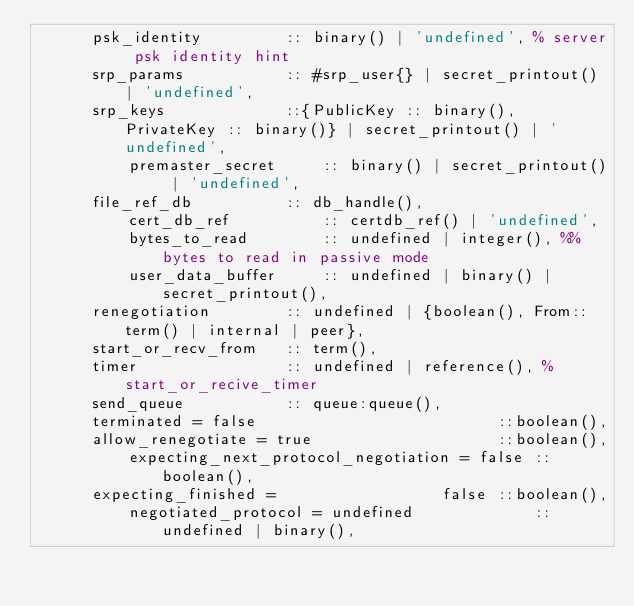Convert code to text. <code><loc_0><loc_0><loc_500><loc_500><_Erlang_>	  psk_identity         :: binary() | 'undefined', % server psk identity hint
	  srp_params           :: #srp_user{} | secret_printout() | 'undefined',
	  srp_keys             ::{PublicKey :: binary(), PrivateKey :: binary()} | secret_printout() | 'undefined',
          premaster_secret     :: binary() | secret_printout() | 'undefined',
	  file_ref_db          :: db_handle(),
          cert_db_ref          :: certdb_ref() | 'undefined',
          bytes_to_read        :: undefined | integer(), %% bytes to read in passive mode
          user_data_buffer     :: undefined | binary() | secret_printout(), 
	  renegotiation        :: undefined | {boolean(), From::term() | internal | peer},
	  start_or_recv_from   :: term(),
	  timer                :: undefined | reference(), % start_or_recive_timer
	  send_queue           :: queue:queue(),
	  terminated = false                          ::boolean(),
	  allow_renegotiate = true                    ::boolean(),
          expecting_next_protocol_negotiation = false ::boolean(),
	  expecting_finished =                  false ::boolean(),
          negotiated_protocol = undefined             :: undefined | binary(),</code> 